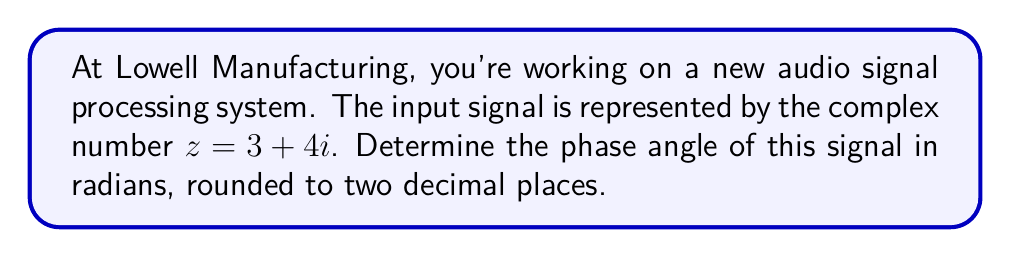Teach me how to tackle this problem. To find the phase angle of a complex number $z = a + bi$, we use the arctangent function:

$$\theta = \arctan\left(\frac{b}{a}\right)$$

Where:
$\theta$ is the phase angle in radians
$a$ is the real part of the complex number
$b$ is the imaginary part of the complex number

For our signal $z = 3 + 4i$:
$a = 3$
$b = 4$

Substituting these values:

$$\theta = \arctan\left(\frac{4}{3}\right)$$

Using a calculator or computer, we can evaluate this:

$$\theta \approx 0.9272952180016122$$

Rounding to two decimal places:

$$\theta \approx 0.93 \text{ radians}$$

Note: It's important to remember that this formula gives the principal value of the argument in the range $(-\frac{\pi}{2}, \frac{\pi}{2})$. In this case, since both the real and imaginary parts are positive, our answer is in the first quadrant and doesn't need adjustment.
Answer: $0.93$ radians 